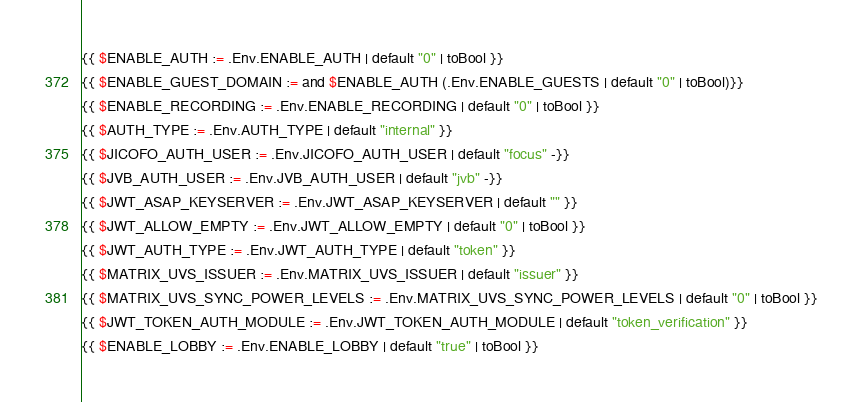<code> <loc_0><loc_0><loc_500><loc_500><_Lua_>{{ $ENABLE_AUTH := .Env.ENABLE_AUTH | default "0" | toBool }}
{{ $ENABLE_GUEST_DOMAIN := and $ENABLE_AUTH (.Env.ENABLE_GUESTS | default "0" | toBool)}}
{{ $ENABLE_RECORDING := .Env.ENABLE_RECORDING | default "0" | toBool }}
{{ $AUTH_TYPE := .Env.AUTH_TYPE | default "internal" }}
{{ $JICOFO_AUTH_USER := .Env.JICOFO_AUTH_USER | default "focus" -}}
{{ $JVB_AUTH_USER := .Env.JVB_AUTH_USER | default "jvb" -}}
{{ $JWT_ASAP_KEYSERVER := .Env.JWT_ASAP_KEYSERVER | default "" }}
{{ $JWT_ALLOW_EMPTY := .Env.JWT_ALLOW_EMPTY | default "0" | toBool }}
{{ $JWT_AUTH_TYPE := .Env.JWT_AUTH_TYPE | default "token" }}
{{ $MATRIX_UVS_ISSUER := .Env.MATRIX_UVS_ISSUER | default "issuer" }}
{{ $MATRIX_UVS_SYNC_POWER_LEVELS := .Env.MATRIX_UVS_SYNC_POWER_LEVELS | default "0" | toBool }}
{{ $JWT_TOKEN_AUTH_MODULE := .Env.JWT_TOKEN_AUTH_MODULE | default "token_verification" }}
{{ $ENABLE_LOBBY := .Env.ENABLE_LOBBY | default "true" | toBool }}</code> 